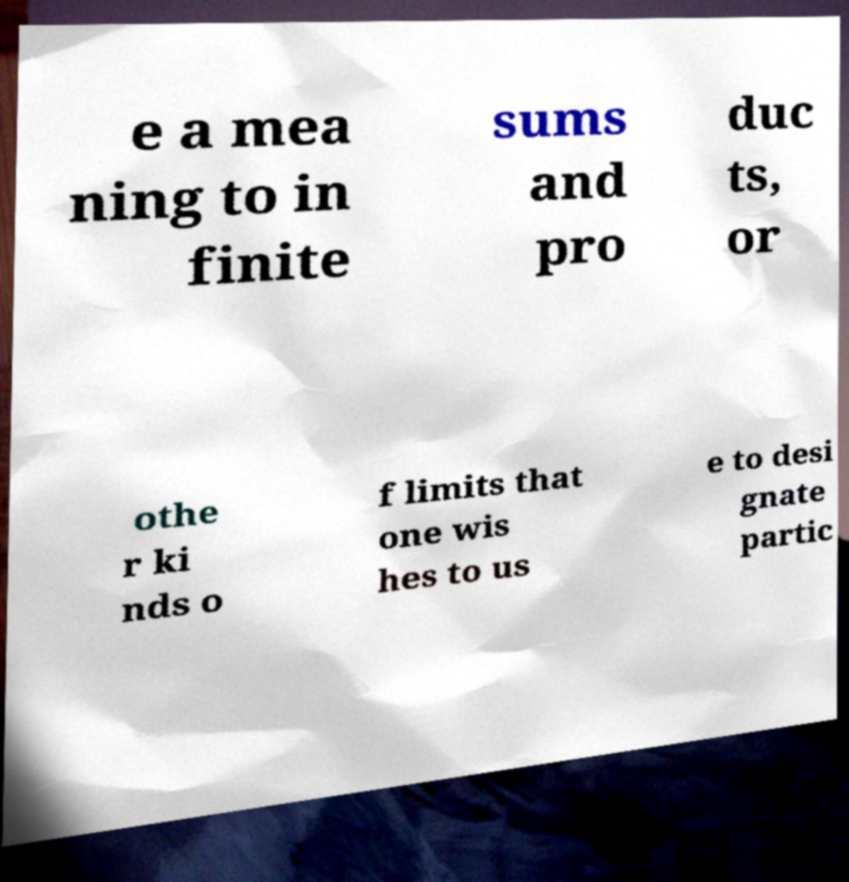Please identify and transcribe the text found in this image. e a mea ning to in finite sums and pro duc ts, or othe r ki nds o f limits that one wis hes to us e to desi gnate partic 